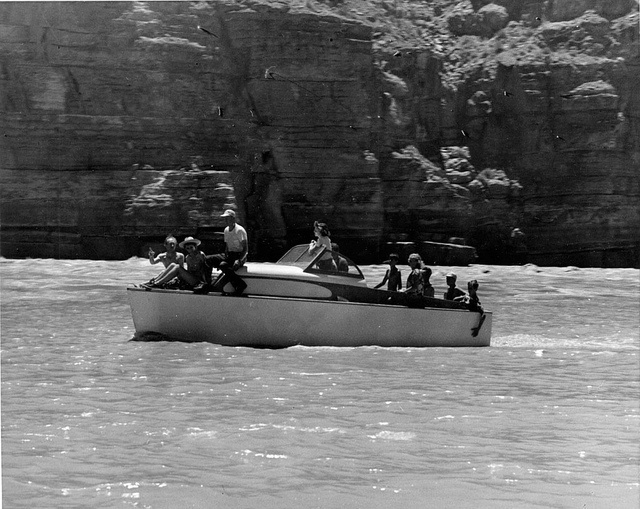Describe the objects in this image and their specific colors. I can see boat in white, gray, black, and lightgray tones, boat in white, black, gray, lightgray, and darkgray tones, people in white, black, gray, darkgray, and lightgray tones, people in white, black, gray, darkgray, and lightgray tones, and people in white, black, gray, darkgray, and lightgray tones in this image. 